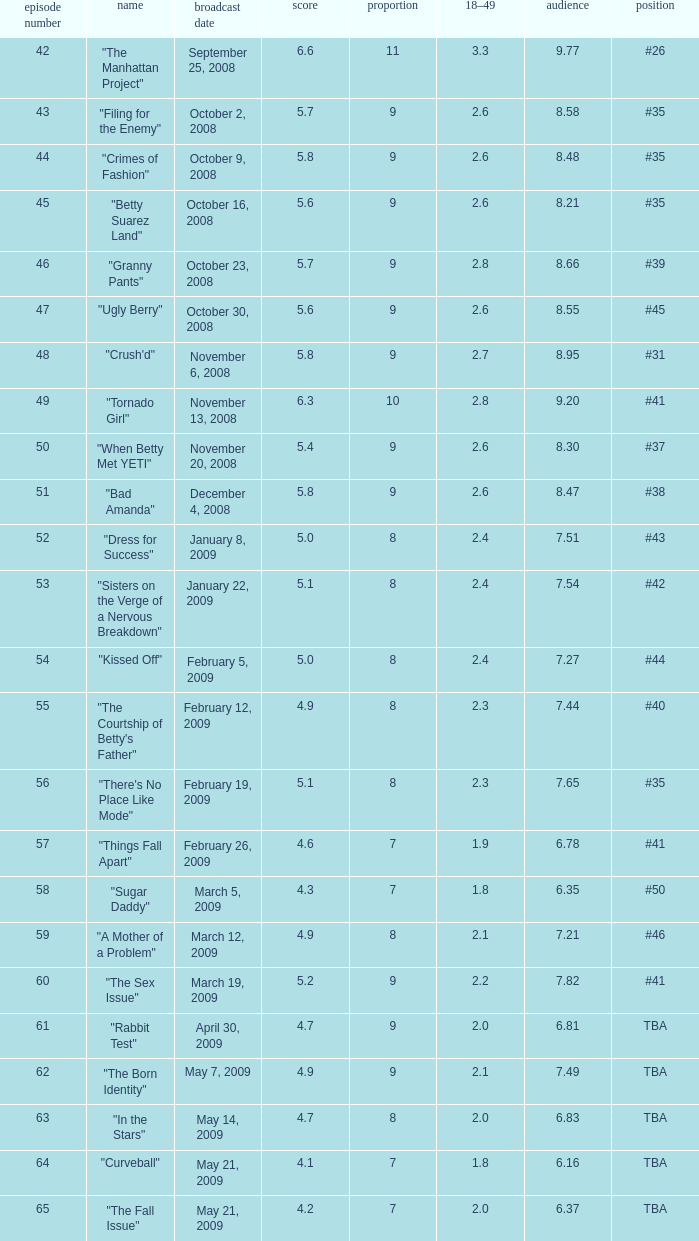What is the average Episode # with a 7 share and 18–49 is less than 2 and the Air Date of may 21, 2009? 64.0. 